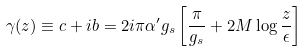Convert formula to latex. <formula><loc_0><loc_0><loc_500><loc_500>\gamma ( z ) \equiv c + i b = 2 i \pi \alpha ^ { \prime } g _ { s } \left [ \frac { \pi } { g _ { s } } + 2 M \log \frac { z } { \epsilon } \right ]</formula> 